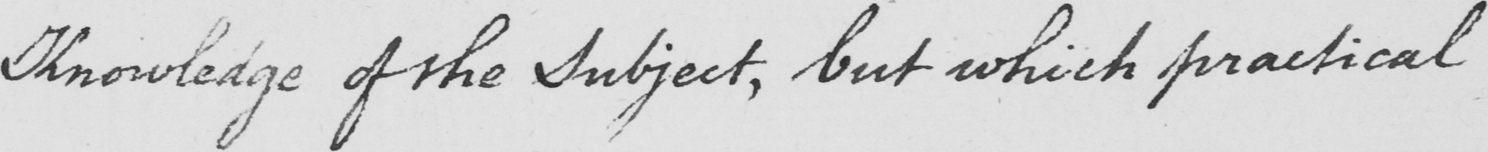Please transcribe the handwritten text in this image. Knowledge of the Subject , but which practical 